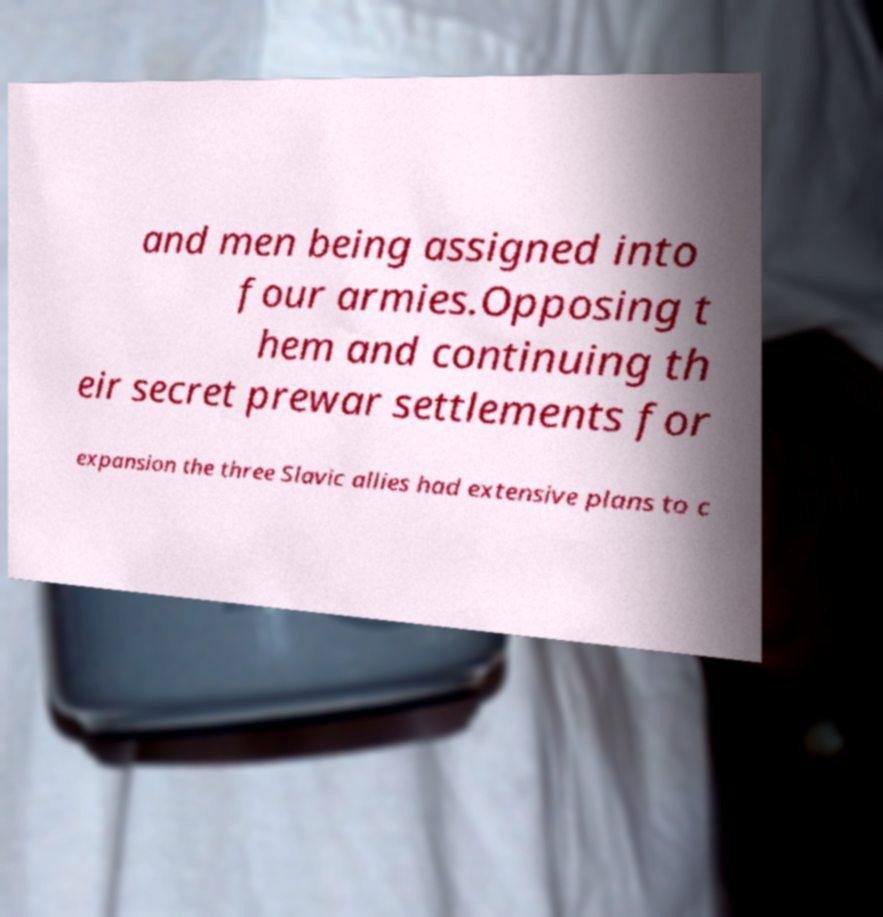Could you assist in decoding the text presented in this image and type it out clearly? and men being assigned into four armies.Opposing t hem and continuing th eir secret prewar settlements for expansion the three Slavic allies had extensive plans to c 